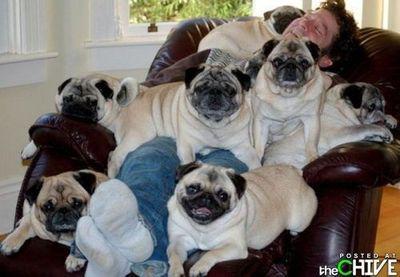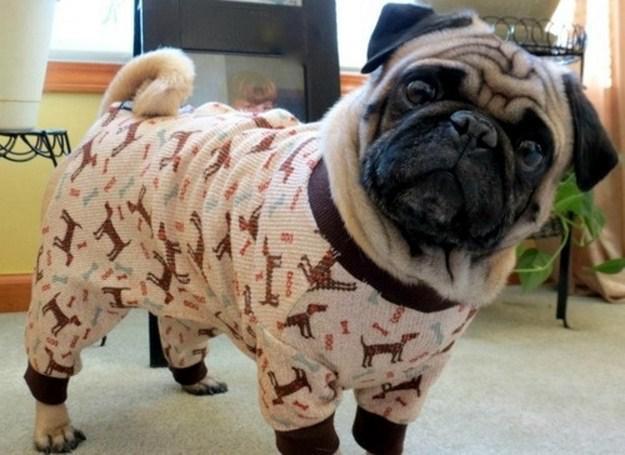The first image is the image on the left, the second image is the image on the right. Examine the images to the left and right. Is the description "There are exactly five dogs in one of the images." accurate? Answer yes or no. No. 